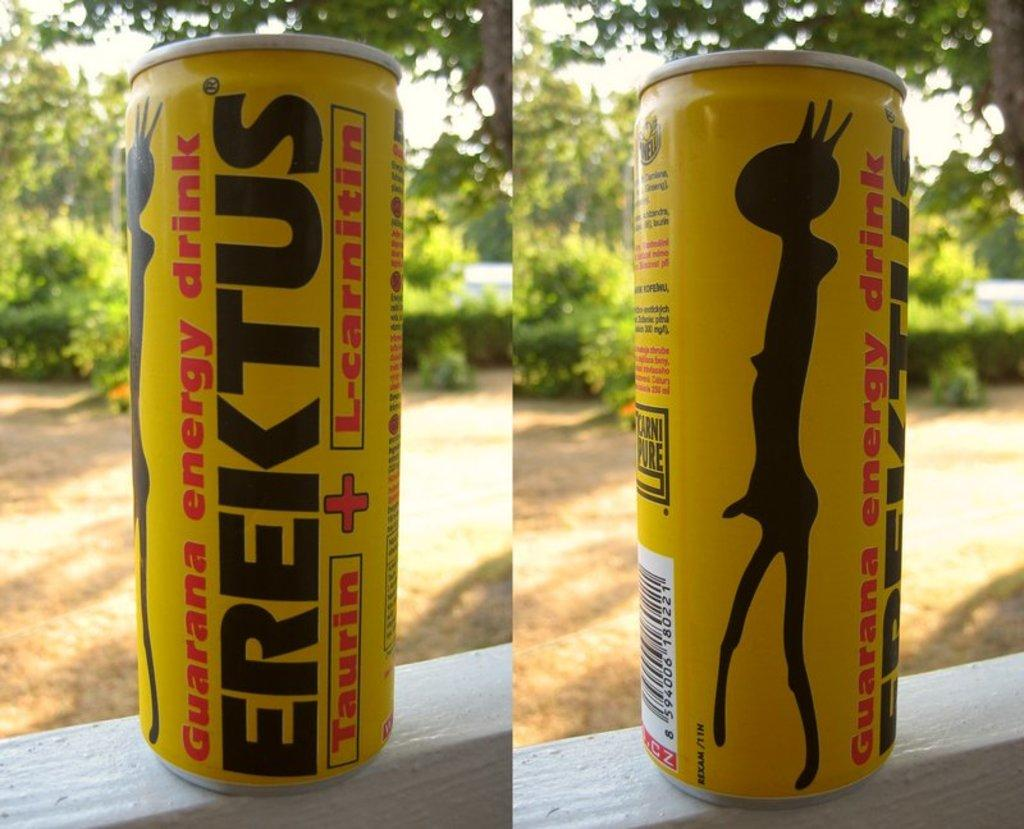<image>
Render a clear and concise summary of the photo. A yellow,red and black can of EREKTUS TAURIN AND L=CARNITIN energy drink. 